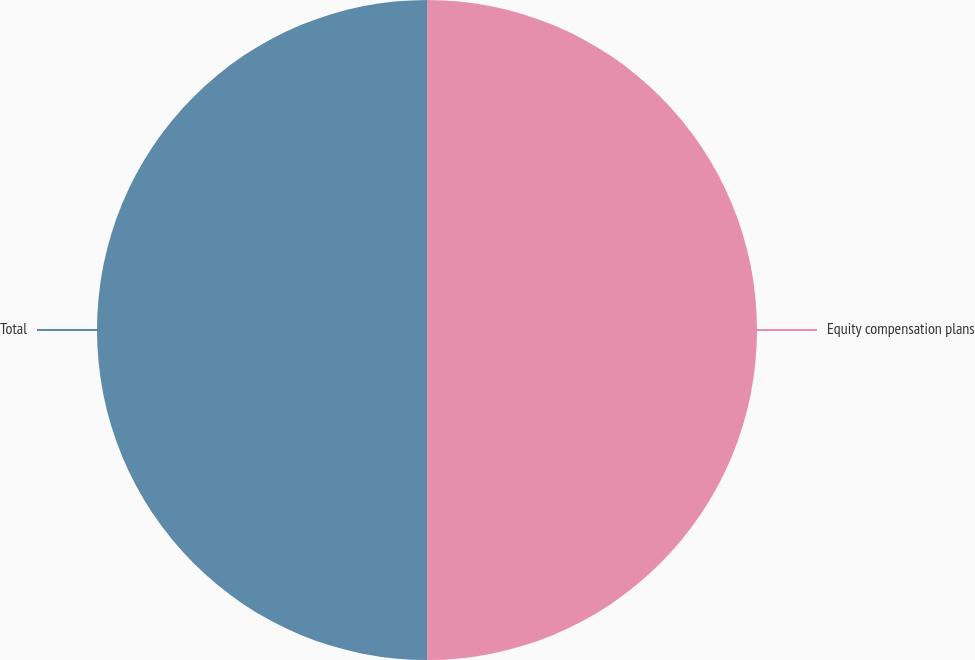<chart> <loc_0><loc_0><loc_500><loc_500><pie_chart><fcel>Equity compensation plans<fcel>Total<nl><fcel>50.0%<fcel>50.0%<nl></chart> 